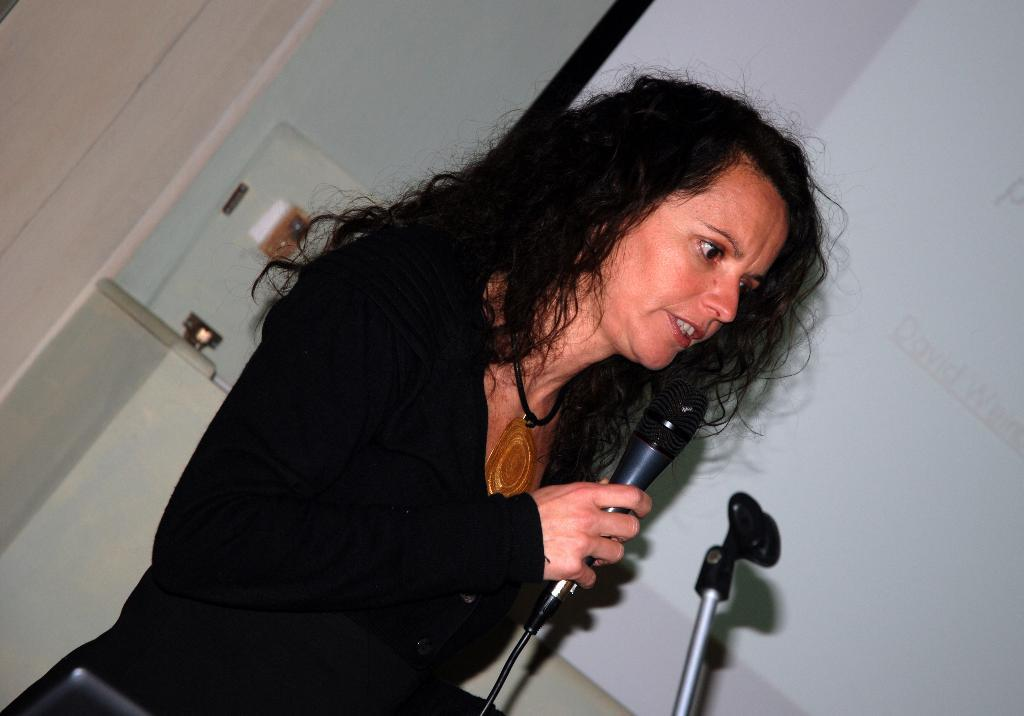Who is the main subject in the image? There is a woman in the image. What is the woman doing in the image? The woman is standing and speaking. What object is the woman holding in her hand? The woman is holding a microphone in her hand. What type of stone is the woman standing on in the image? There is no stone visible in the image; the woman is standing on a surface that is not described in the facts. 